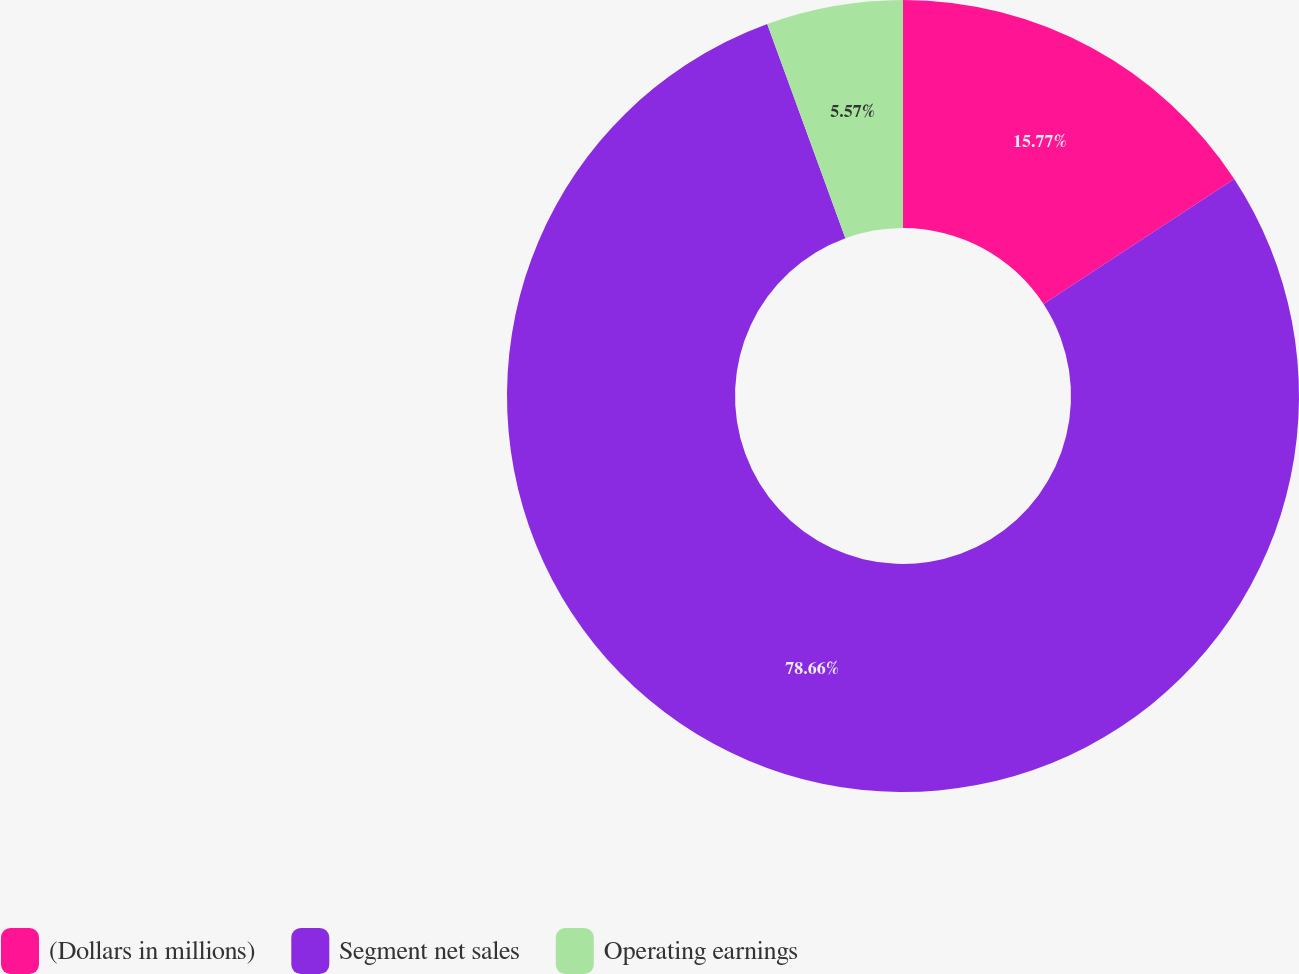Convert chart to OTSL. <chart><loc_0><loc_0><loc_500><loc_500><pie_chart><fcel>(Dollars in millions)<fcel>Segment net sales<fcel>Operating earnings<nl><fcel>15.77%<fcel>78.66%<fcel>5.57%<nl></chart> 